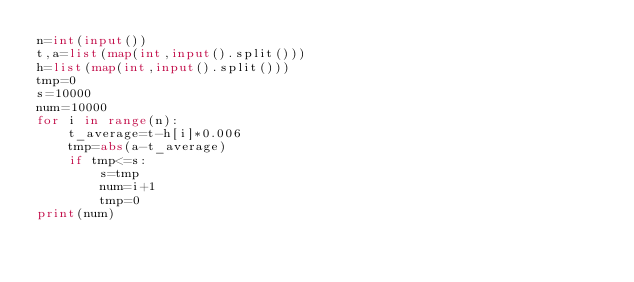Convert code to text. <code><loc_0><loc_0><loc_500><loc_500><_Python_>n=int(input())
t,a=list(map(int,input().split()))
h=list(map(int,input().split()))
tmp=0
s=10000
num=10000
for i in range(n):
    t_average=t-h[i]*0.006
    tmp=abs(a-t_average)
    if tmp<=s:
        s=tmp
        num=i+1
        tmp=0
print(num)</code> 